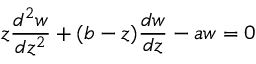Convert formula to latex. <formula><loc_0><loc_0><loc_500><loc_500>z { \frac { d ^ { 2 } w } { d z ^ { 2 } } } + ( b - z ) { \frac { d w } { d z } } - a w = 0</formula> 